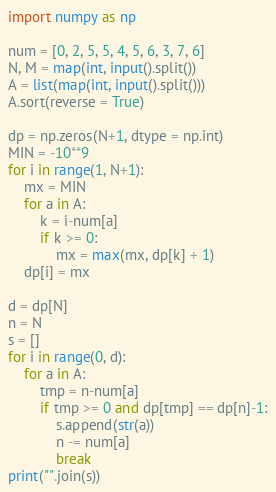<code> <loc_0><loc_0><loc_500><loc_500><_Python_>import numpy as np

num = [0, 2, 5, 5, 4, 5, 6, 3, 7, 6]
N, M = map(int, input().split())
A = list(map(int, input().split()))
A.sort(reverse = True)

dp = np.zeros(N+1, dtype = np.int)
MIN = -10**9
for i in range(1, N+1):
    mx = MIN
    for a in A:
        k = i-num[a]
        if k >= 0:
            mx = max(mx, dp[k] + 1)
    dp[i] = mx

d = dp[N]
n = N
s = []
for i in range(0, d):
    for a in A:
        tmp = n-num[a]
        if tmp >= 0 and dp[tmp] == dp[n]-1:
            s.append(str(a))
            n -= num[a]
            break
print("".join(s))
</code> 